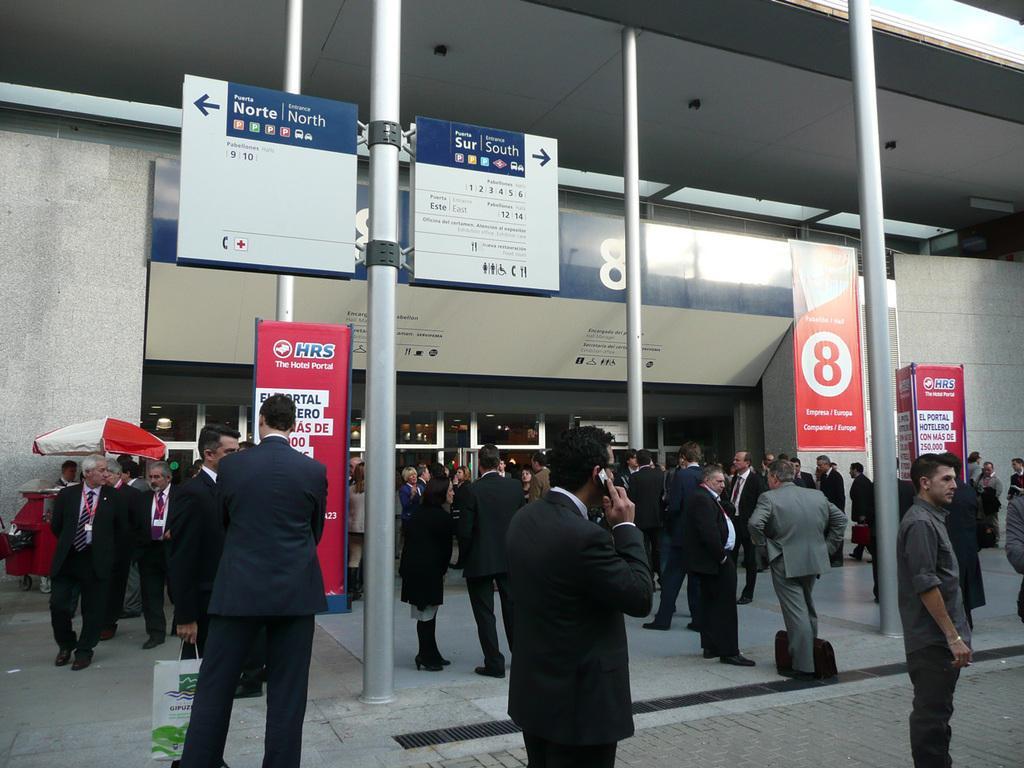Please provide a concise description of this image. In this picture, we see many people are standing. In the middle, there are poles. The man on the left side is holding a white and green color plastic bag. Behind him, we see a board in red color with some text written on it. At the top, we see two boards in white and blue color with some text written on it. On the right side, we see a white wall. Beside that, we see the boards in red color with some text written on it. On the left side, we see a tent in white and red color and people are standing under the tent. In the background, we see a building. 